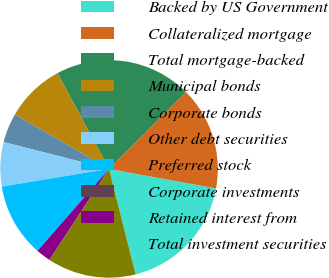Convert chart to OTSL. <chart><loc_0><loc_0><loc_500><loc_500><pie_chart><fcel>Backed by US Government<fcel>Collateralized mortgage<fcel>Total mortgage-backed<fcel>Municipal bonds<fcel>Corporate bonds<fcel>Other debt securities<fcel>Preferred stock<fcel>Corporate investments<fcel>Retained interest from<fcel>Total investment securities<nl><fcel>18.19%<fcel>15.36%<fcel>20.38%<fcel>8.78%<fcel>4.39%<fcel>6.58%<fcel>10.97%<fcel>0.0%<fcel>2.2%<fcel>13.16%<nl></chart> 